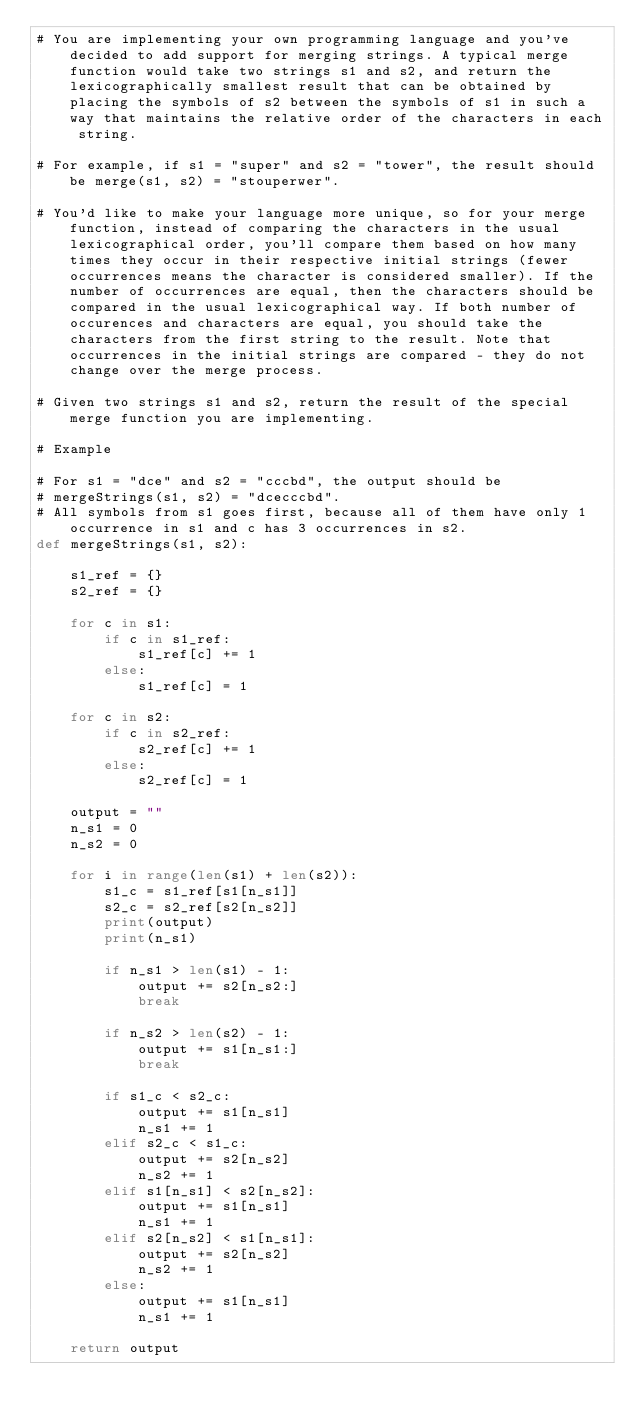Convert code to text. <code><loc_0><loc_0><loc_500><loc_500><_Python_># You are implementing your own programming language and you've decided to add support for merging strings. A typical merge function would take two strings s1 and s2, and return the lexicographically smallest result that can be obtained by placing the symbols of s2 between the symbols of s1 in such a way that maintains the relative order of the characters in each string.

# For example, if s1 = "super" and s2 = "tower", the result should be merge(s1, s2) = "stouperwer".

# You'd like to make your language more unique, so for your merge function, instead of comparing the characters in the usual lexicographical order, you'll compare them based on how many times they occur in their respective initial strings (fewer occurrences means the character is considered smaller). If the number of occurrences are equal, then the characters should be compared in the usual lexicographical way. If both number of occurences and characters are equal, you should take the characters from the first string to the result. Note that occurrences in the initial strings are compared - they do not change over the merge process.

# Given two strings s1 and s2, return the result of the special merge function you are implementing.

# Example 

# For s1 = "dce" and s2 = "cccbd", the output should be
# mergeStrings(s1, s2) = "dcecccbd".
# All symbols from s1 goes first, because all of them have only 1 occurrence in s1 and c has 3 occurrences in s2.
def mergeStrings(s1, s2):

    s1_ref = {}
    s2_ref = {}
    
    for c in s1:
        if c in s1_ref:
            s1_ref[c] += 1
        else: 
            s1_ref[c] = 1
            
    for c in s2:
        if c in s2_ref:
            s2_ref[c] += 1
        else: 
            s2_ref[c] = 1
    
    output = ""
    n_s1 = 0
    n_s2 = 0
    
    for i in range(len(s1) + len(s2)):
        s1_c = s1_ref[s1[n_s1]]
        s2_c = s2_ref[s2[n_s2]]
        print(output)
        print(n_s1)
        
        if n_s1 > len(s1) - 1:
            output += s2[n_s2:]
            break
        
        if n_s2 > len(s2) - 1:
            output += s1[n_s1:]
            break
        
        if s1_c < s2_c:
            output += s1[n_s1]
            n_s1 += 1
        elif s2_c < s1_c:
            output += s2[n_s2]
            n_s2 += 1
        elif s1[n_s1] < s2[n_s2]:
            output += s1[n_s1]
            n_s1 += 1
        elif s2[n_s2] < s1[n_s1]:
            output += s2[n_s2]
            n_s2 += 1
        else:
            output += s1[n_s1]
            n_s1 += 1
    
    return output
</code> 